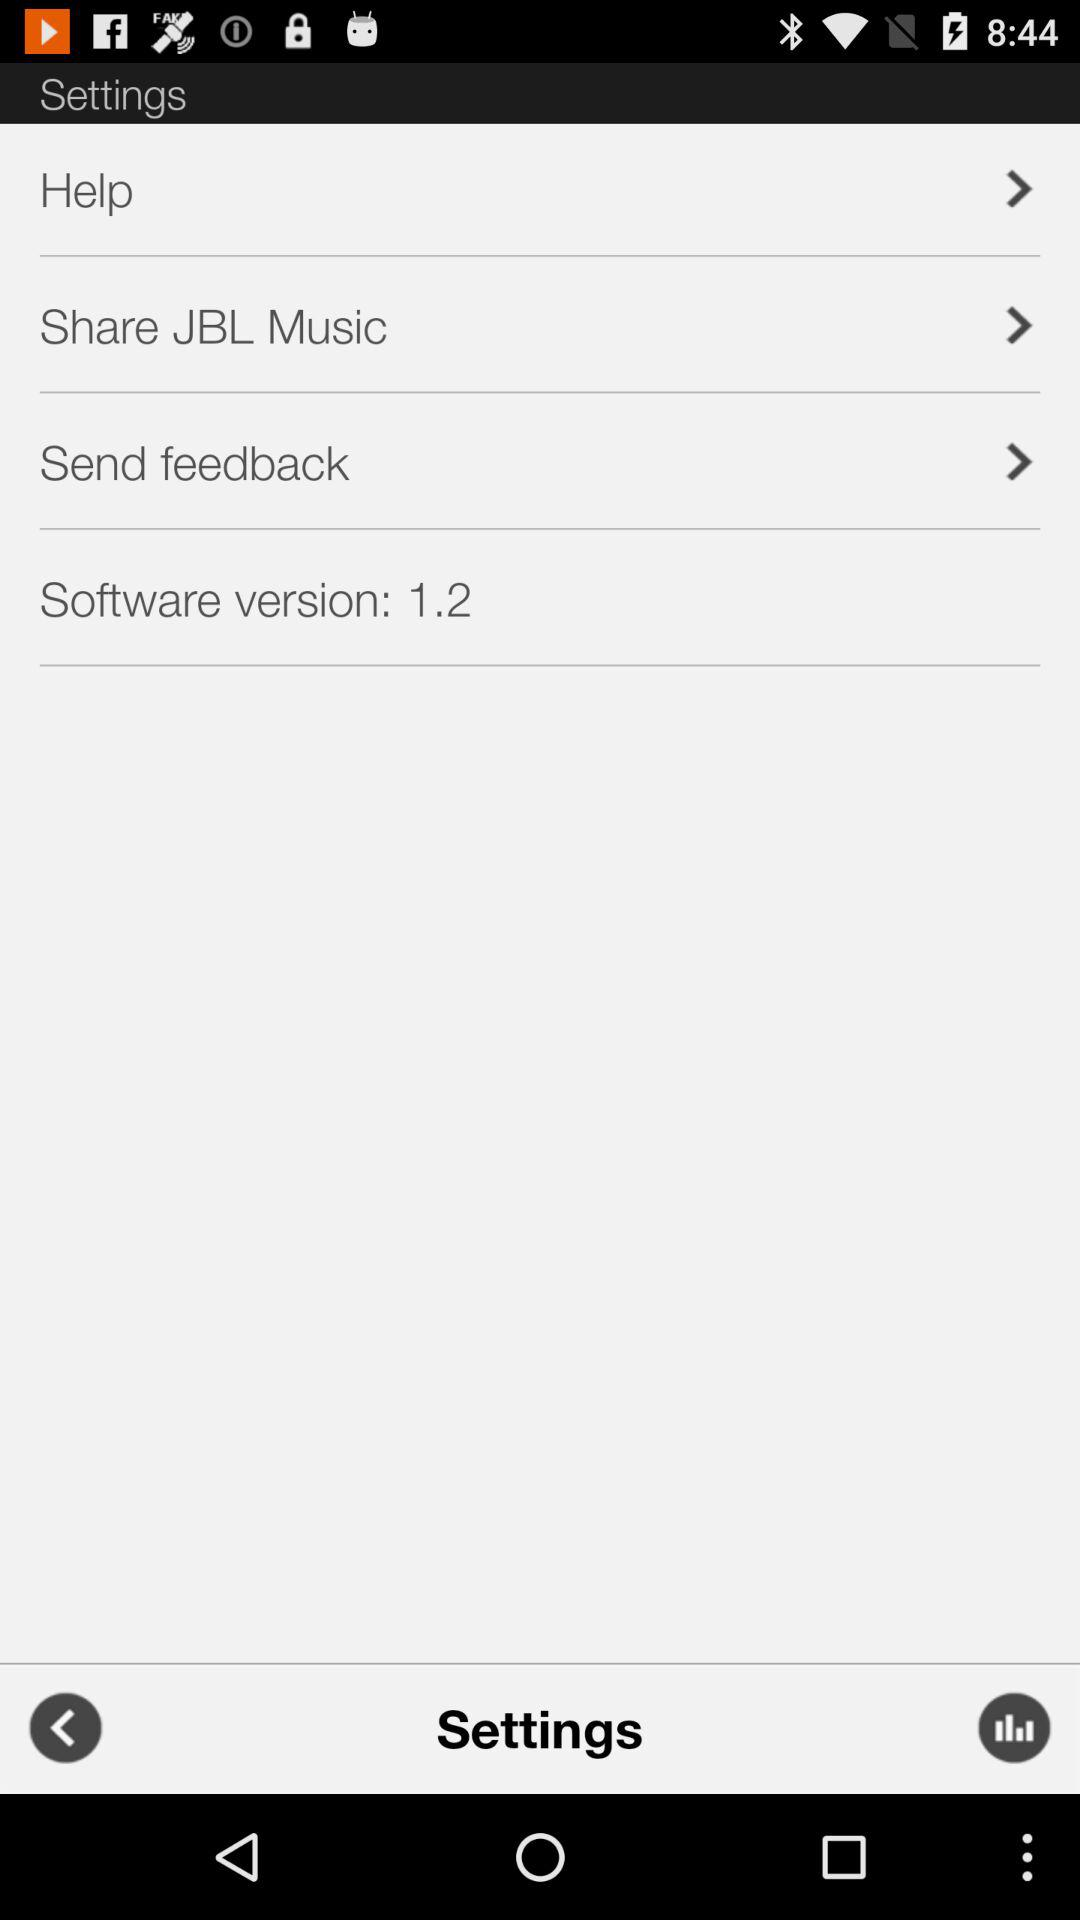What is the software version? The software version is 1.2. 